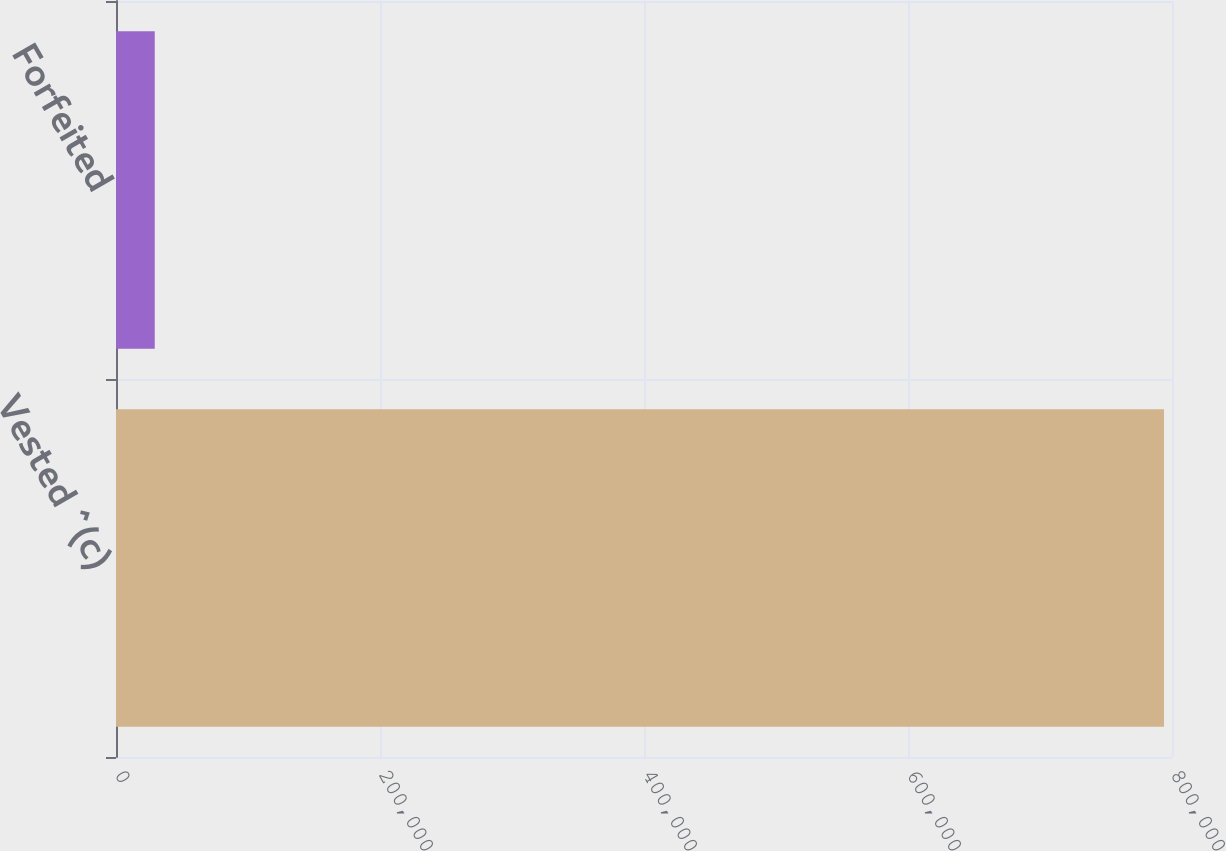<chart> <loc_0><loc_0><loc_500><loc_500><bar_chart><fcel>Vested ^(c)<fcel>Forfeited<nl><fcel>793955<fcel>29356<nl></chart> 